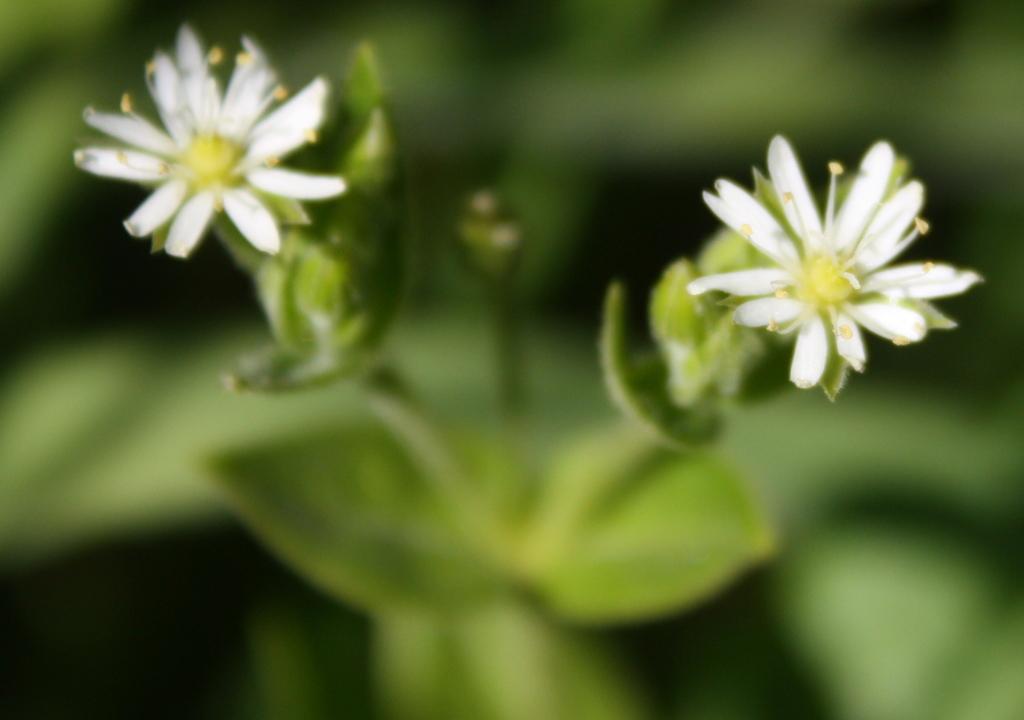How would you summarize this image in a sentence or two? In this image we can see a plant with flowers and the background is blurred. 